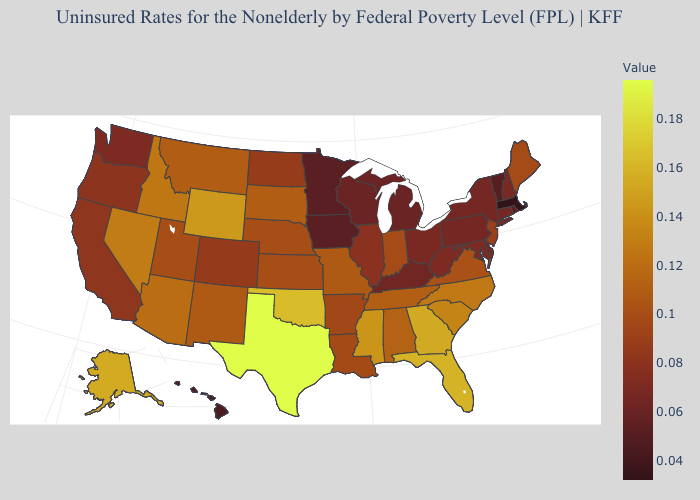Among the states that border Tennessee , does Missouri have the lowest value?
Write a very short answer. No. Does Virginia have the highest value in the South?
Short answer required. No. Does New Mexico have a higher value than California?
Answer briefly. Yes. Does Utah have a lower value than Florida?
Give a very brief answer. Yes. Which states have the lowest value in the West?
Quick response, please. Hawaii. Among the states that border Virginia , which have the highest value?
Answer briefly. North Carolina. Among the states that border Missouri , does Oklahoma have the highest value?
Give a very brief answer. Yes. 